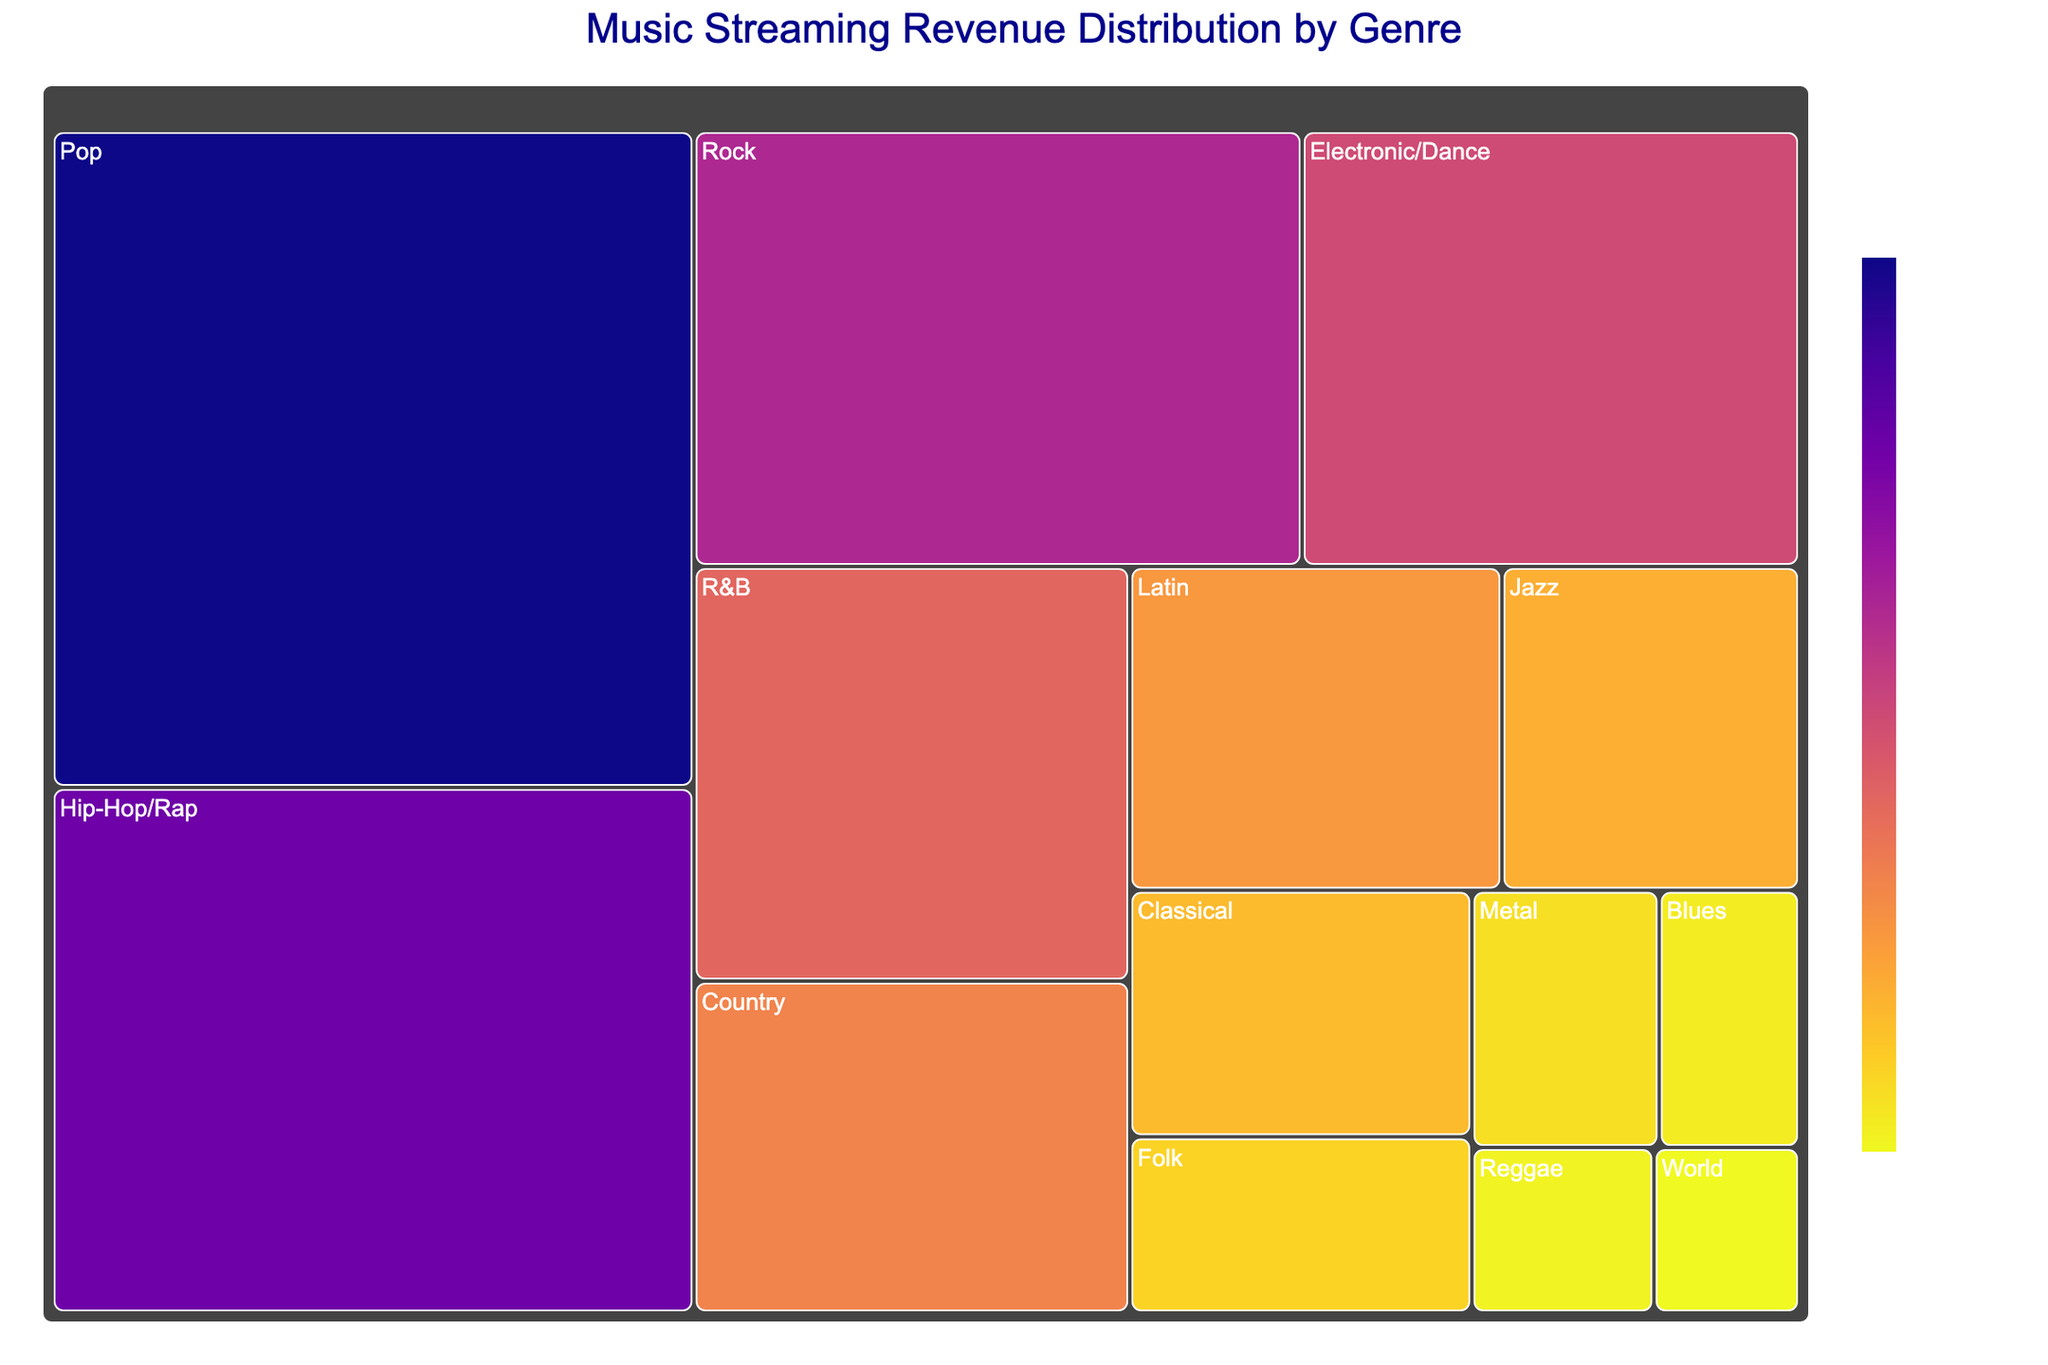What's the title of the figure? The title is prominently displayed at the top of the figure in the largest font size. It provides a summary of what the treemap depicts.
Answer: Music Streaming Revenue Distribution by Genre Which genre has the highest revenue? The treemap visualization shows the size of each rectangle proportional to its revenue. The largest rectangle represents the genre with the highest revenue.
Answer: Pop What is the revenue for Rock? Hovering over the "Rock" section of the treemap reveals the exact revenue.
Answer: $220,000,000 How much more revenue does Pop have compared to Country? First, identify the revenue for Pop and Country, then subtract the Country revenue from the Pop revenue: $350M (Pop) - $120M (Country).
Answer: $230,000,000 What percentage of the total revenue does Hip-Hop/Rap contribute? Calculate it by dividing Hip-Hop/Rap revenue by the total revenue, then multiply by 100: \[ (280M / (350M + 280M + 220M + 180M + 150M + 120M + 100M + 80M + 70M + 50M + 40M + 30M + 25M + 20M)) * 100 \approx 19.93\% \]
Answer: 19.93% How many genres have a revenue of at least $100,000,000? Count the number of rectangles that have values greater than or equal to $100,000,000.
Answer: 7 Which genres have a revenue less than $50,000,000? Identify genres with rectangles representing revenues below $50,000,000. These include Folk, Metal, Blues, Reggae, and World.
Answer: Folk, Metal, Blues, Reggae, World What is the combined revenue of the three genres with the lowest revenue? Identify the three genres with the smallest rectangles: Blues ($30M), Reggae ($25M), and World ($20M). Sum these values: 30M + 25M + 20M.
Answer: $75,000,000 Does the Electronic/Dance genre generate more revenue than R&B? Compare the values of Electronic/Dance ($180M) and R&B ($150M).
Answer: Yes What is the average revenue per genre? Calculate the total revenue and divide by the number of genres: \[ \text{Total Revenue} = 350M + 280M + 220M + 180M + 150M + 120M + 100M + 80M + 70M + 50M + 40M + 30M + 25M + 20M \] Divided by 14 (the number of genres). \[ \text{Average revenue} = \frac{1715M}{14} \approx 122.5M \]
Answer: $122,500,000 